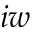<formula> <loc_0><loc_0><loc_500><loc_500>i w</formula> 